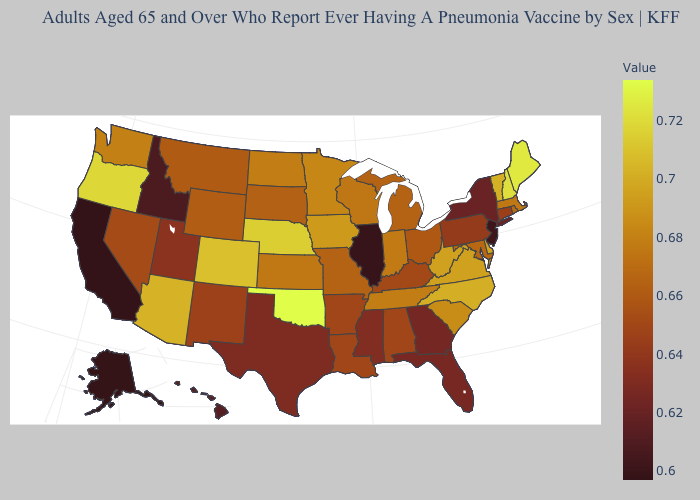Does the map have missing data?
Answer briefly. No. Which states have the lowest value in the Northeast?
Be succinct. New Jersey. Does the map have missing data?
Write a very short answer. No. Does Minnesota have the highest value in the MidWest?
Quick response, please. No. Does Oregon have the highest value in the West?
Concise answer only. Yes. Which states have the highest value in the USA?
Quick response, please. Oklahoma. Does Wisconsin have the lowest value in the MidWest?
Concise answer only. No. Does Maryland have the lowest value in the South?
Short answer required. No. 